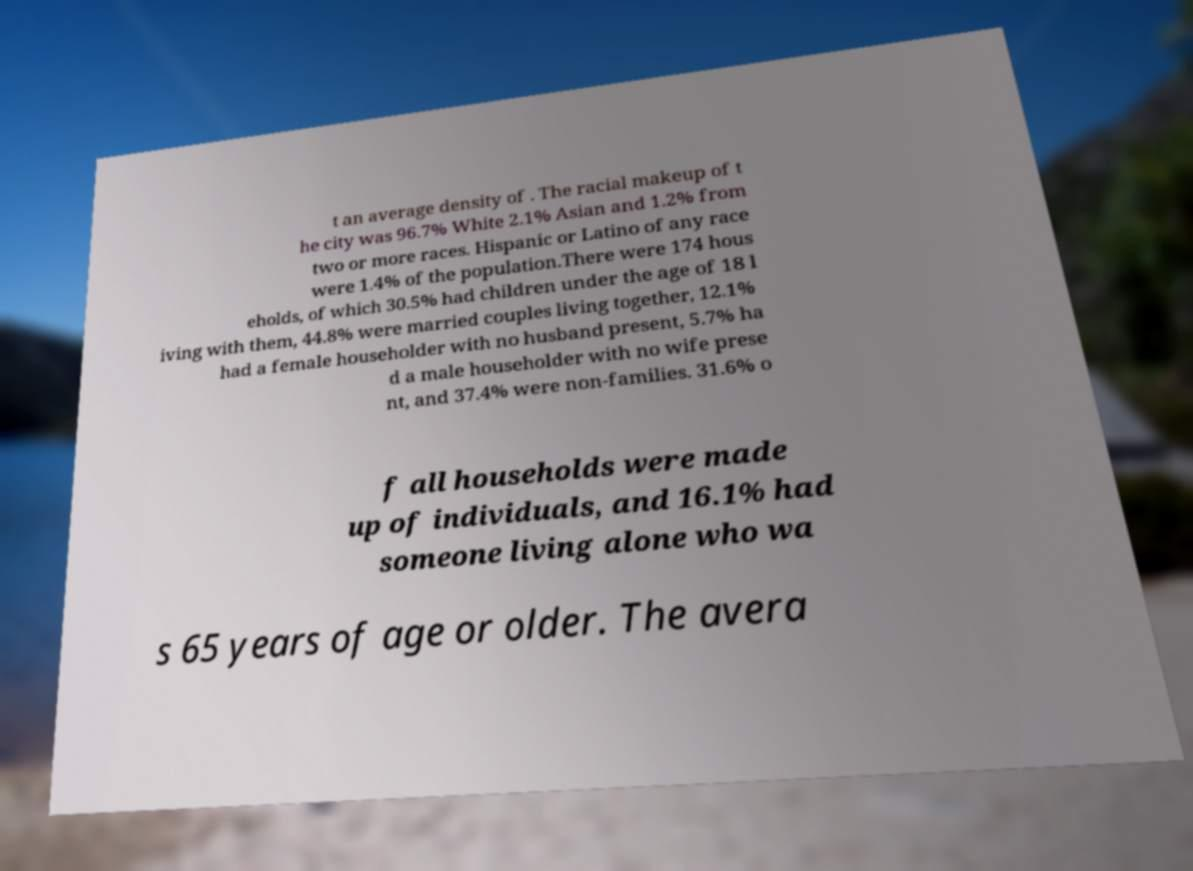There's text embedded in this image that I need extracted. Can you transcribe it verbatim? t an average density of . The racial makeup of t he city was 96.7% White 2.1% Asian and 1.2% from two or more races. Hispanic or Latino of any race were 1.4% of the population.There were 174 hous eholds, of which 30.5% had children under the age of 18 l iving with them, 44.8% were married couples living together, 12.1% had a female householder with no husband present, 5.7% ha d a male householder with no wife prese nt, and 37.4% were non-families. 31.6% o f all households were made up of individuals, and 16.1% had someone living alone who wa s 65 years of age or older. The avera 